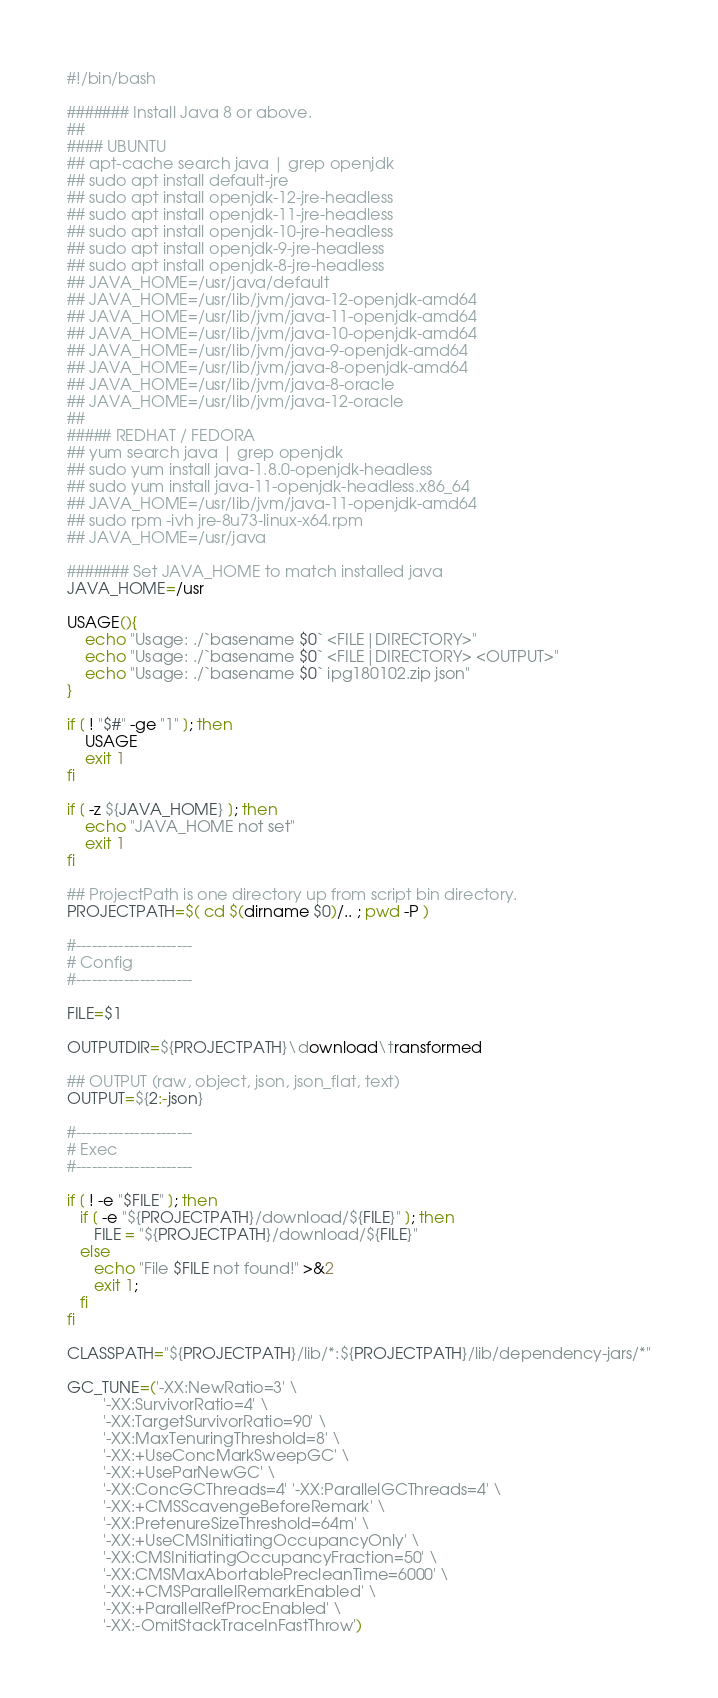Convert code to text. <code><loc_0><loc_0><loc_500><loc_500><_Bash_>#!/bin/bash

####### Install Java 8 or above.
##
#### UBUNTU
## apt-cache search java | grep openjdk
## sudo apt install default-jre
## sudo apt install openjdk-12-jre-headless
## sudo apt install openjdk-11-jre-headless
## sudo apt install openjdk-10-jre-headless
## sudo apt install openjdk-9-jre-headless
## sudo apt install openjdk-8-jre-headless
## JAVA_HOME=/usr/java/default
## JAVA_HOME=/usr/lib/jvm/java-12-openjdk-amd64
## JAVA_HOME=/usr/lib/jvm/java-11-openjdk-amd64
## JAVA_HOME=/usr/lib/jvm/java-10-openjdk-amd64
## JAVA_HOME=/usr/lib/jvm/java-9-openjdk-amd64
## JAVA_HOME=/usr/lib/jvm/java-8-openjdk-amd64
## JAVA_HOME=/usr/lib/jvm/java-8-oracle
## JAVA_HOME=/usr/lib/jvm/java-12-oracle
##
##### REDHAT / FEDORA
## yum search java | grep openjdk
## sudo yum install java-1.8.0-openjdk-headless
## sudo yum install java-11-openjdk-headless.x86_64
## JAVA_HOME=/usr/lib/jvm/java-11-openjdk-amd64
## sudo rpm -ivh jre-8u73-linux-x64.rpm
## JAVA_HOME=/usr/java

####### Set JAVA_HOME to match installed java
JAVA_HOME=/usr

USAGE(){
    echo "Usage: ./`basename $0` <FILE|DIRECTORY>"
    echo "Usage: ./`basename $0` <FILE|DIRECTORY> <OUTPUT>"
    echo "Usage: ./`basename $0` ipg180102.zip json"
}

if [ ! "$#" -ge "1" ]; then
    USAGE
    exit 1
fi

if [ -z ${JAVA_HOME} ]; then
	echo "JAVA_HOME not set"
	exit 1
fi

## ProjectPath is one directory up from script bin directory.
PROJECTPATH=$( cd $(dirname $0)/.. ; pwd -P )

#----------------------
# Config
#----------------------

FILE=$1

OUTPUTDIR=${PROJECTPATH}\download\transformed

## OUTPUT (raw, object, json, json_flat, text)
OUTPUT=${2:-json}

#----------------------
# Exec
#----------------------

if [ ! -e "$FILE" ]; then
   if [ -e "${PROJECTPATH}/download/${FILE}" ]; then
	  FILE = "${PROJECTPATH}/download/${FILE}"
   else
      echo "File $FILE not found!" >&2
	  exit 1;
   fi
fi

CLASSPATH="${PROJECTPATH}/lib/*:${PROJECTPATH}/lib/dependency-jars/*"

GC_TUNE=('-XX:NewRatio=3' \
        '-XX:SurvivorRatio=4' \
        '-XX:TargetSurvivorRatio=90' \
        '-XX:MaxTenuringThreshold=8' \
        '-XX:+UseConcMarkSweepGC' \
        '-XX:+UseParNewGC' \
        '-XX:ConcGCThreads=4' '-XX:ParallelGCThreads=4' \
        '-XX:+CMSScavengeBeforeRemark' \
        '-XX:PretenureSizeThreshold=64m' \
        '-XX:+UseCMSInitiatingOccupancyOnly' \
        '-XX:CMSInitiatingOccupancyFraction=50' \
        '-XX:CMSMaxAbortablePrecleanTime=6000' \
        '-XX:+CMSParallelRemarkEnabled' \
        '-XX:+ParallelRefProcEnabled' \
        '-XX:-OmitStackTraceInFastThrow')
</code> 